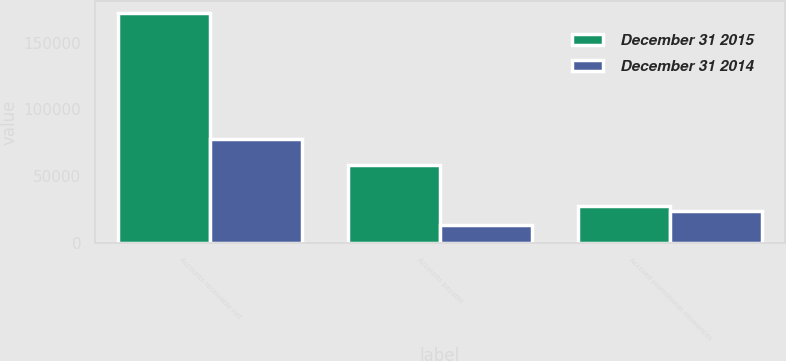<chart> <loc_0><loc_0><loc_500><loc_500><stacked_bar_chart><ecel><fcel>Accounts receivable net<fcel>Accounts payable<fcel>Accrued promotional allowances<nl><fcel>December 31 2015<fcel>172201<fcel>58579<fcel>27544<nl><fcel>December 31 2014<fcel>78011<fcel>13738<fcel>23776<nl></chart> 